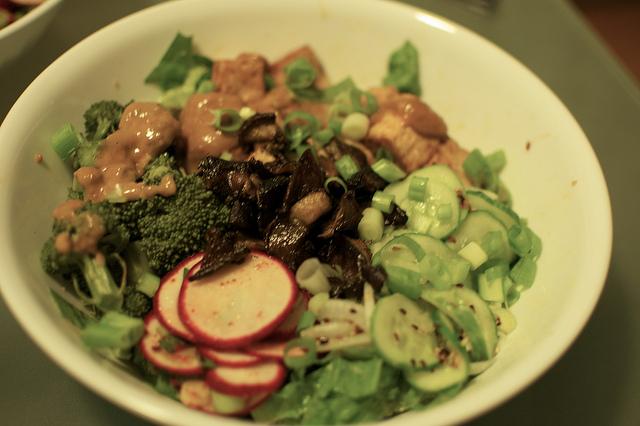What color is the plate?
Give a very brief answer. White. Is there dressing on this salad?
Write a very short answer. Yes. What is sprinkled over the broccoli?
Concise answer only. Pepper. Did you add tomatoes to your salad?
Answer briefly. No. What kind of dressing appears to be on this salad?
Keep it brief. Thousand island. Is the bowl white?
Short answer required. Yes. Is there tofu in the salad?
Short answer required. No. Are there scallions in the salad?
Quick response, please. Yes. Is there a serving spoon in the bowl?
Answer briefly. No. Does this appear to be a traditional African meal?
Quick response, please. No. 